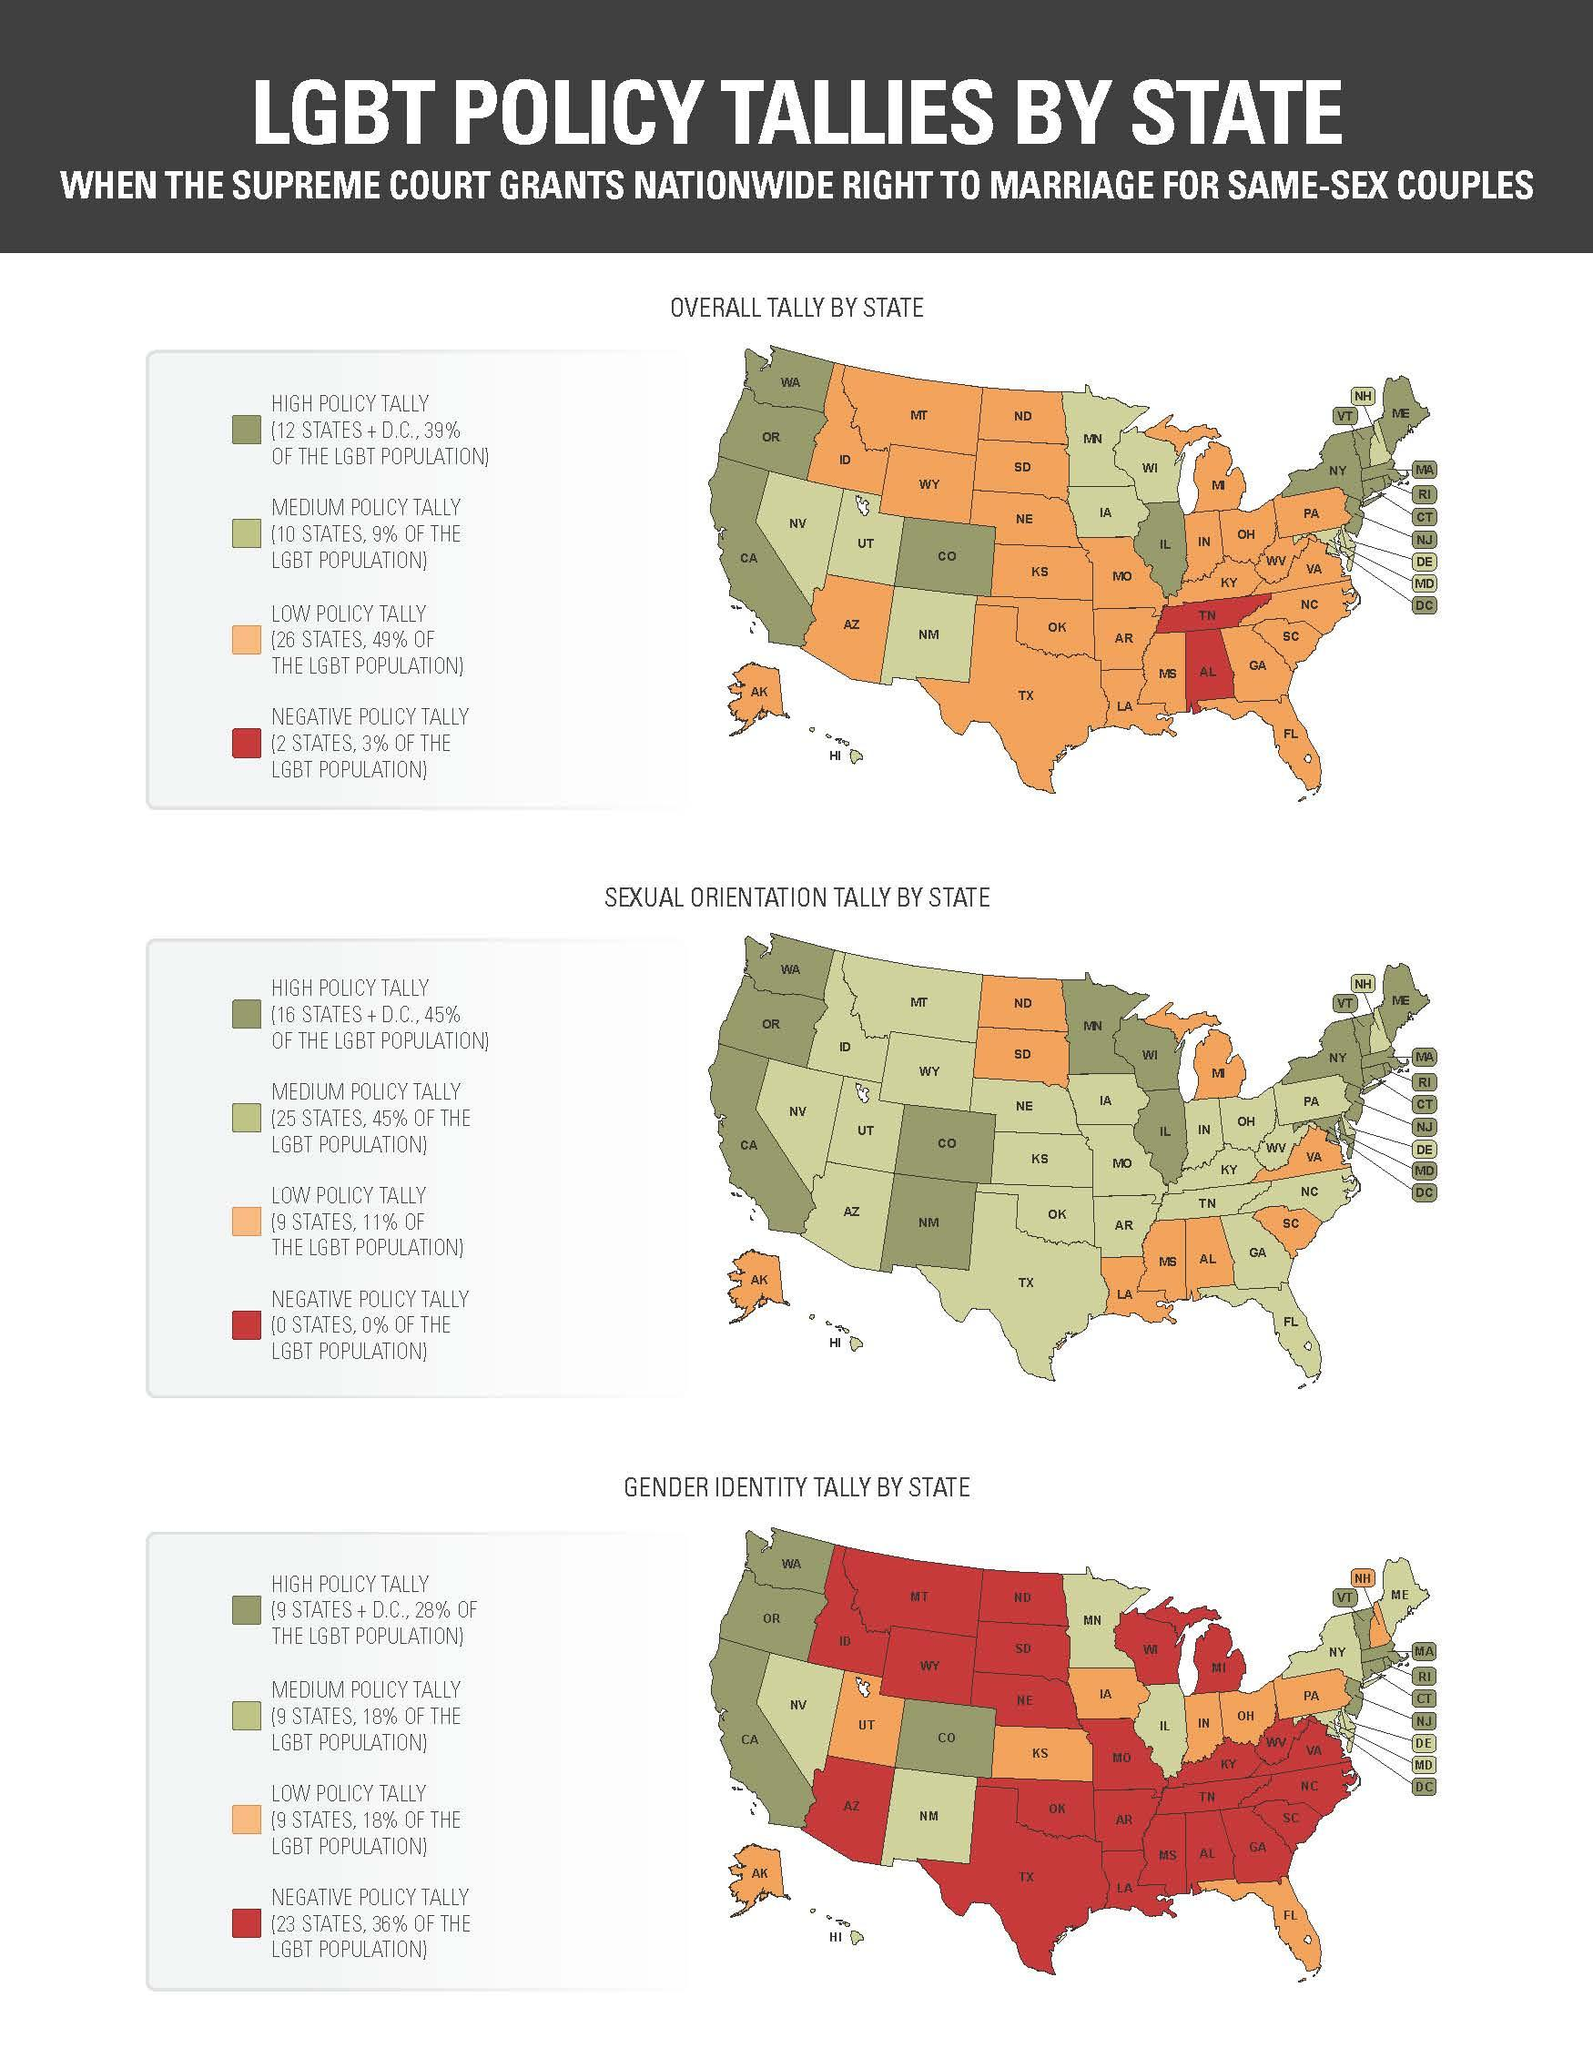Draw attention to some important aspects in this diagram. The gender identity tally by state shows that Alaska has a low policy tally, indicating a lack of support for transgender and gender non-conforming individuals in the state. According to the overall tally by state, it appears that the island with the lowest policy tally is Alaska. According to the overall tally by state, certain states have a negative policy tally, including Tennessee and Alabama. According to the sexual orientation tally by state, the island with the lowest policy tally is Alaska. 